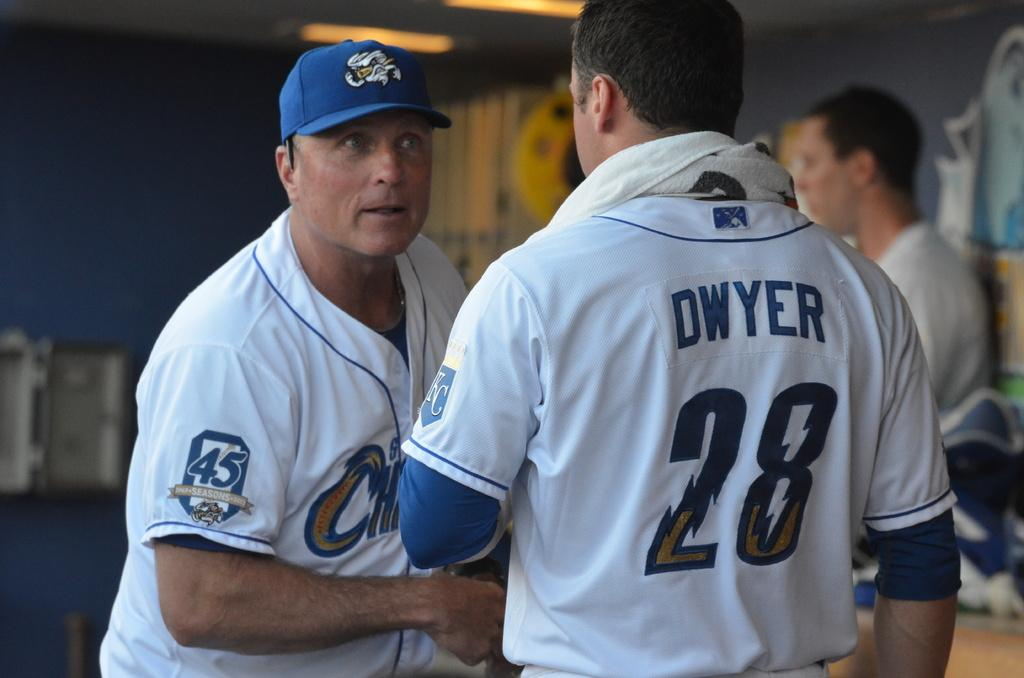<image>
Share a concise interpretation of the image provided. ballplayer talking to another player, #28 dwyer with another player in the background 